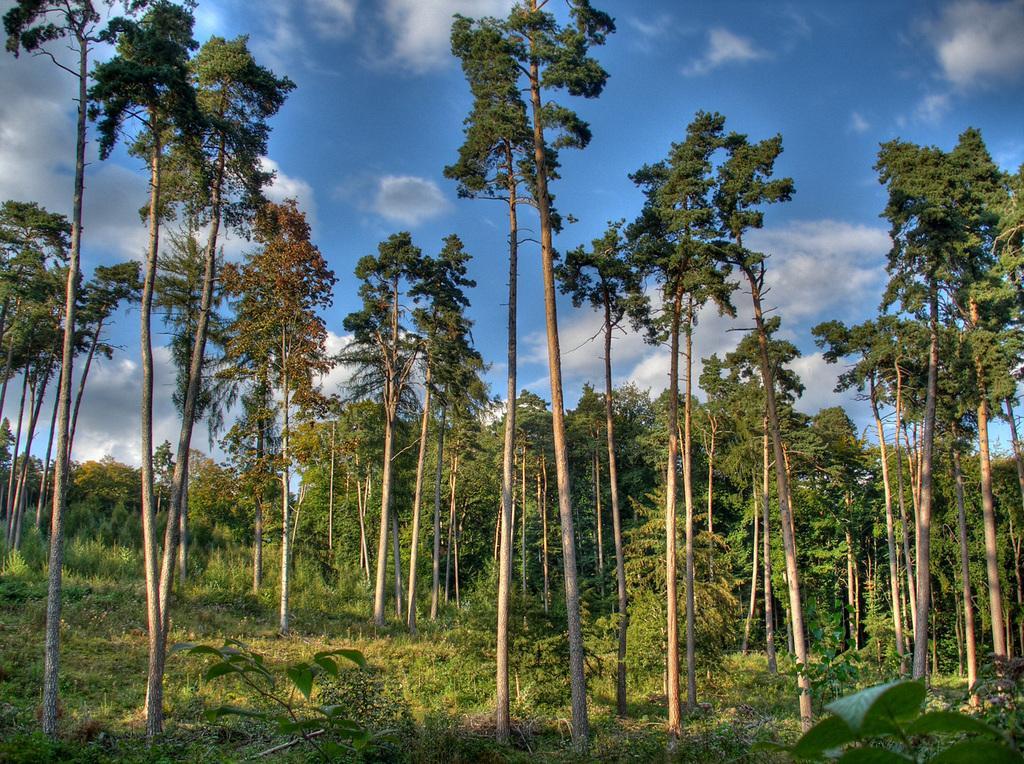Can you describe this image briefly? In this picture we can see trees, at the bottom there is grass, we can see the sky at the top of the picture. 